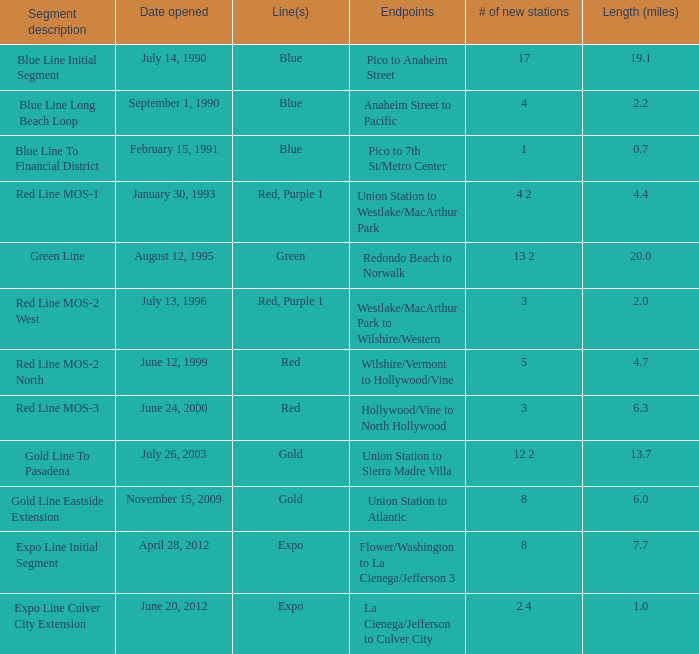When does the segment description red line mos-2 north open? June 12, 1999. Parse the table in full. {'header': ['Segment description', 'Date opened', 'Line(s)', 'Endpoints', '# of new stations', 'Length (miles)'], 'rows': [['Blue Line Initial Segment', 'July 14, 1990', 'Blue', 'Pico to Anaheim Street', '17', '19.1'], ['Blue Line Long Beach Loop', 'September 1, 1990', 'Blue', 'Anaheim Street to Pacific', '4', '2.2'], ['Blue Line To Financial District', 'February 15, 1991', 'Blue', 'Pico to 7th St/Metro Center', '1', '0.7'], ['Red Line MOS-1', 'January 30, 1993', 'Red, Purple 1', 'Union Station to Westlake/MacArthur Park', '4 2', '4.4'], ['Green Line', 'August 12, 1995', 'Green', 'Redondo Beach to Norwalk', '13 2', '20.0'], ['Red Line MOS-2 West', 'July 13, 1996', 'Red, Purple 1', 'Westlake/MacArthur Park to Wilshire/Western', '3', '2.0'], ['Red Line MOS-2 North', 'June 12, 1999', 'Red', 'Wilshire/Vermont to Hollywood/Vine', '5', '4.7'], ['Red Line MOS-3', 'June 24, 2000', 'Red', 'Hollywood/Vine to North Hollywood', '3', '6.3'], ['Gold Line To Pasadena', 'July 26, 2003', 'Gold', 'Union Station to Sierra Madre Villa', '12 2', '13.7'], ['Gold Line Eastside Extension', 'November 15, 2009', 'Gold', 'Union Station to Atlantic', '8', '6.0'], ['Expo Line Initial Segment', 'April 28, 2012', 'Expo', 'Flower/Washington to La Cienega/Jefferson 3', '8', '7.7'], ['Expo Line Culver City Extension', 'June 20, 2012', 'Expo', 'La Cienega/Jefferson to Culver City', '2 4', '1.0']]} 